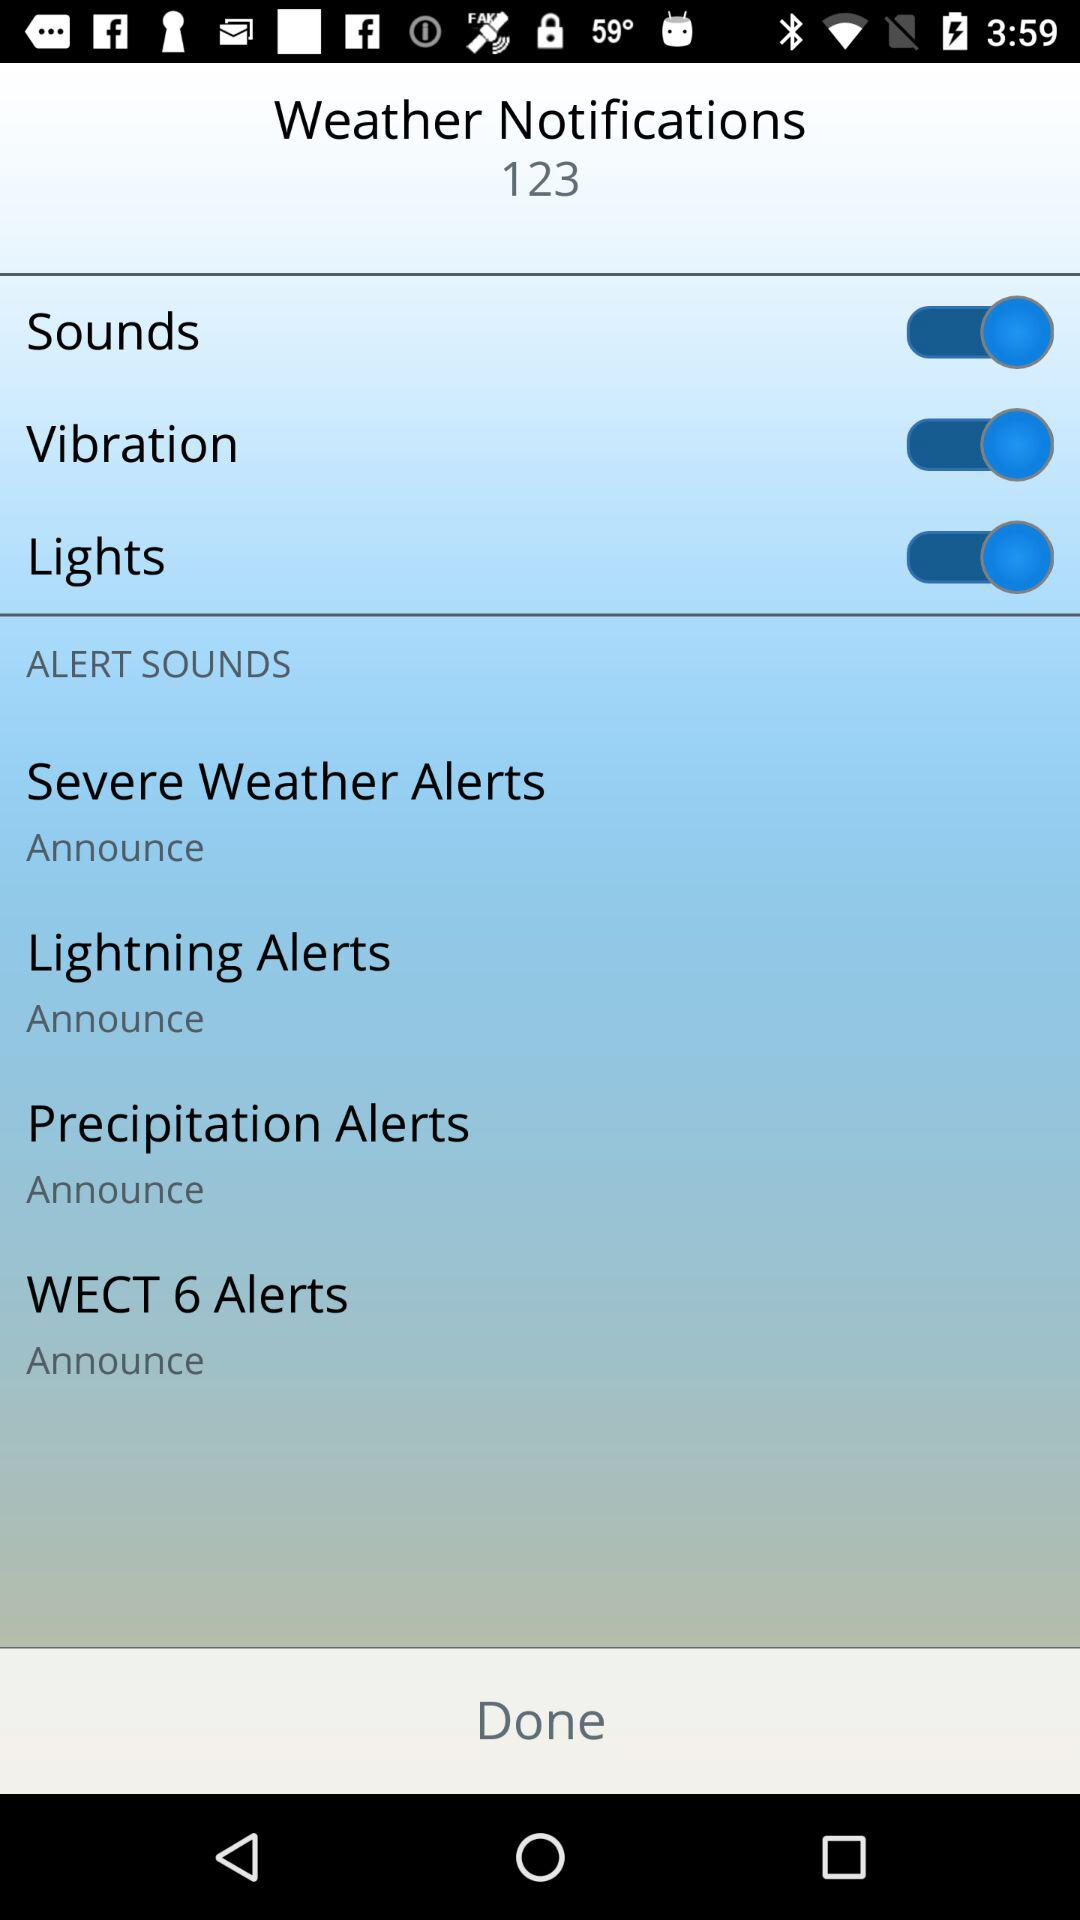What is the status of "Lights"? The status is "on". 